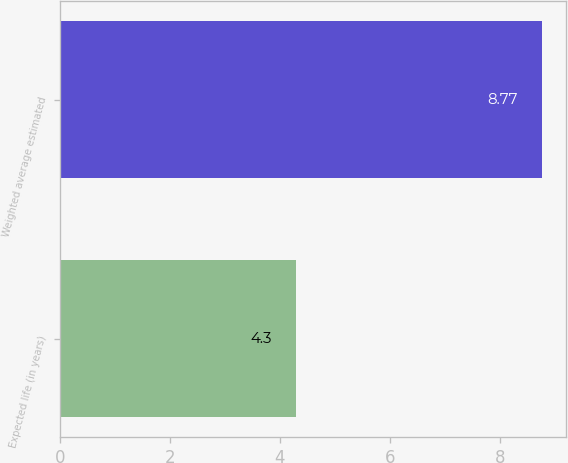Convert chart to OTSL. <chart><loc_0><loc_0><loc_500><loc_500><bar_chart><fcel>Expected life (in years)<fcel>Weighted average estimated<nl><fcel>4.3<fcel>8.77<nl></chart> 